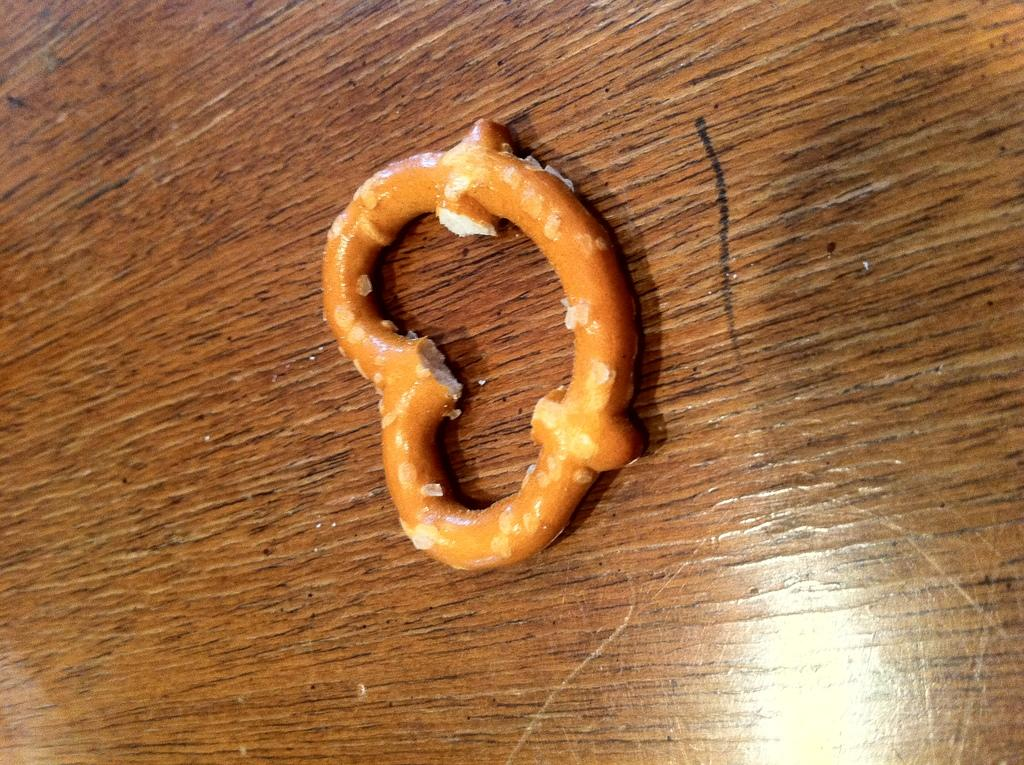What type of surface is visible in the image? There is a wooden surface in the image. What is on top of the wooden surface? There is food on the wooden surface. How much force is being applied to the wooden surface by the oranges in the image? There are no oranges present in the image, so it is not possible to determine the force being applied by them. 